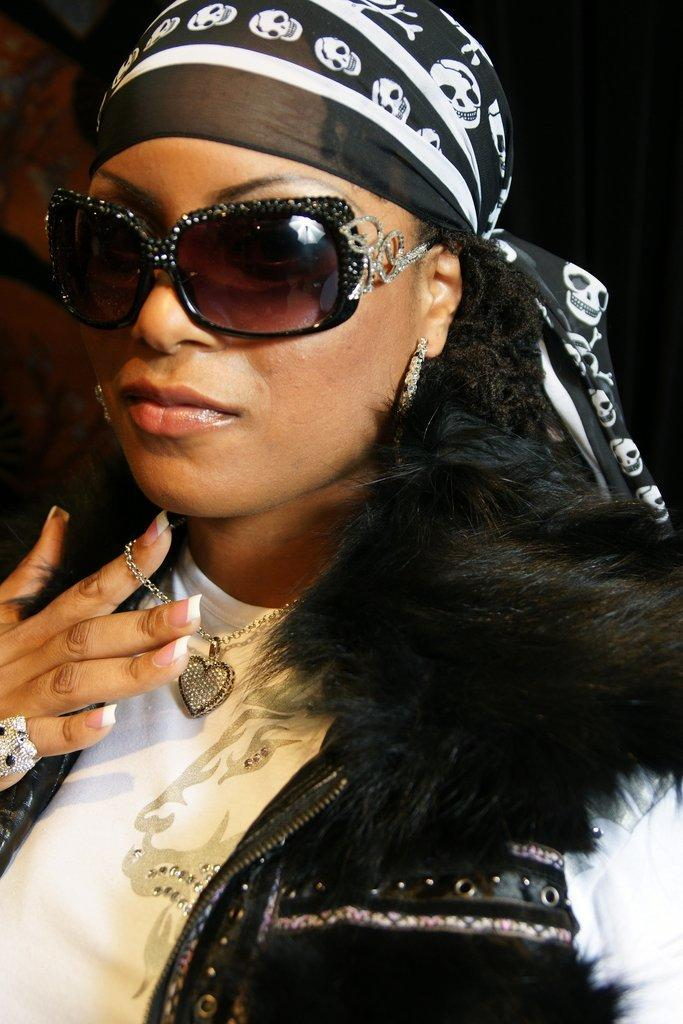Who is the main subject in the image? There is a woman in the image. What is the woman wearing on her face? The woman is wearing goggles. What color is the woman's t-shirt? The woman is wearing a white color t-shirt. What color is the woman's coat? The woman is wearing a black color coat. What type of paste is the woman using to apply on her hair in the image? There is no paste visible in the image, and the woman's hair does not appear to be styled with any paste. 